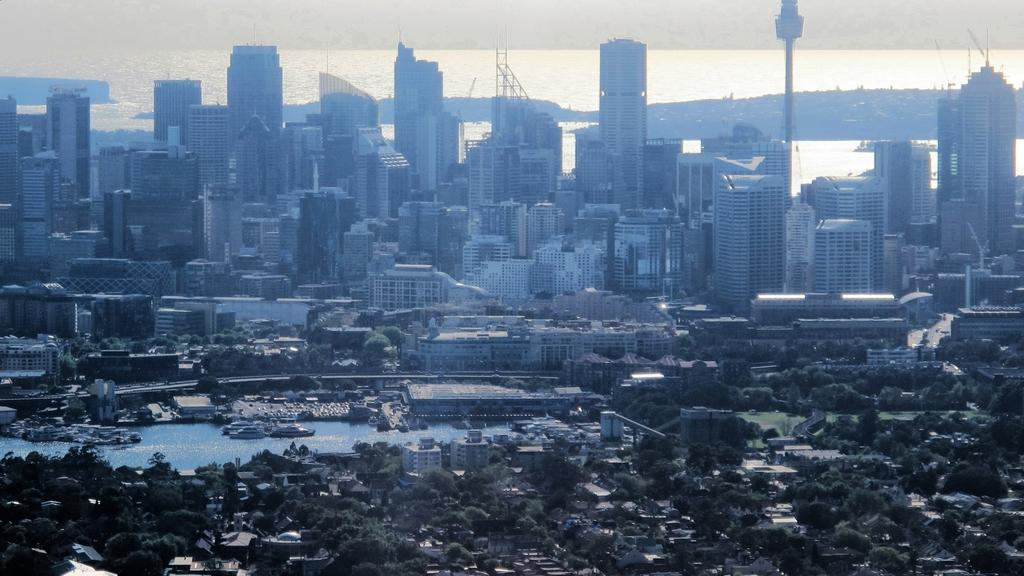What type of structures can be seen in the image? There are buildings in the image. What natural elements are present in the image? There are trees and water visible in the image. What object can be seen in the water? There is a rod in the water in the image. What type of transportation is present in the image? There are boats and vehicles in the image. Where is the majority of the water located in the image? The top of the image contains water. How many frogs are sitting on the vehicles in the image? There are no frogs present in the image; it features buildings, trees, water, a rod, boats, and vehicles. What type of health advice can be seen on the buildings in the image? There is no health advice visible on the buildings in the image. 